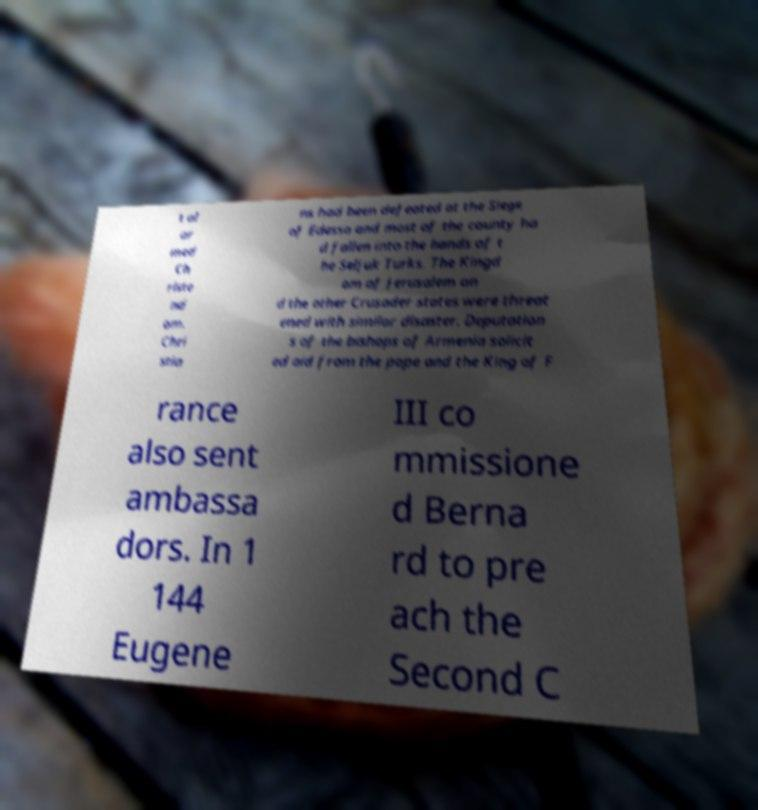Can you accurately transcribe the text from the provided image for me? t al ar med Ch riste nd om. Chri stia ns had been defeated at the Siege of Edessa and most of the county ha d fallen into the hands of t he Seljuk Turks. The Kingd om of Jerusalem an d the other Crusader states were threat ened with similar disaster. Deputation s of the bishops of Armenia solicit ed aid from the pope and the King of F rance also sent ambassa dors. In 1 144 Eugene III co mmissione d Berna rd to pre ach the Second C 